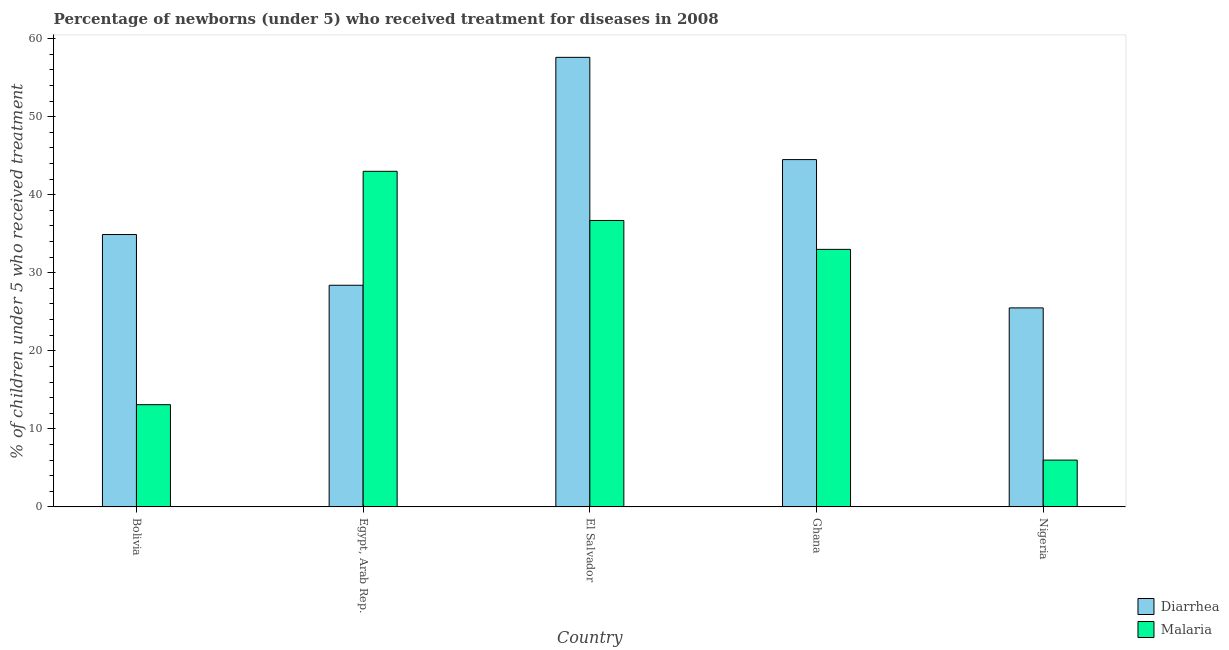How many different coloured bars are there?
Ensure brevity in your answer.  2. How many groups of bars are there?
Your response must be concise. 5. Are the number of bars on each tick of the X-axis equal?
Keep it short and to the point. Yes. What is the label of the 2nd group of bars from the left?
Provide a succinct answer. Egypt, Arab Rep. In how many cases, is the number of bars for a given country not equal to the number of legend labels?
Provide a short and direct response. 0. Across all countries, what is the maximum percentage of children who received treatment for malaria?
Your answer should be compact. 43. In which country was the percentage of children who received treatment for malaria maximum?
Offer a terse response. Egypt, Arab Rep. In which country was the percentage of children who received treatment for diarrhoea minimum?
Offer a very short reply. Nigeria. What is the total percentage of children who received treatment for malaria in the graph?
Provide a succinct answer. 131.8. What is the difference between the percentage of children who received treatment for diarrhoea in Bolivia and that in El Salvador?
Your answer should be very brief. -22.7. What is the difference between the percentage of children who received treatment for malaria in Bolivia and the percentage of children who received treatment for diarrhoea in El Salvador?
Give a very brief answer. -44.5. What is the average percentage of children who received treatment for malaria per country?
Your answer should be very brief. 26.36. What is the difference between the percentage of children who received treatment for malaria and percentage of children who received treatment for diarrhoea in Ghana?
Provide a short and direct response. -11.5. In how many countries, is the percentage of children who received treatment for malaria greater than 22 %?
Make the answer very short. 3. What is the ratio of the percentage of children who received treatment for malaria in El Salvador to that in Ghana?
Your response must be concise. 1.11. Is the difference between the percentage of children who received treatment for malaria in Egypt, Arab Rep. and El Salvador greater than the difference between the percentage of children who received treatment for diarrhoea in Egypt, Arab Rep. and El Salvador?
Provide a short and direct response. Yes. What is the difference between the highest and the second highest percentage of children who received treatment for malaria?
Offer a terse response. 6.3. What is the difference between the highest and the lowest percentage of children who received treatment for diarrhoea?
Provide a succinct answer. 32.1. In how many countries, is the percentage of children who received treatment for malaria greater than the average percentage of children who received treatment for malaria taken over all countries?
Provide a short and direct response. 3. Is the sum of the percentage of children who received treatment for diarrhoea in Bolivia and Ghana greater than the maximum percentage of children who received treatment for malaria across all countries?
Ensure brevity in your answer.  Yes. What does the 2nd bar from the left in Ghana represents?
Keep it short and to the point. Malaria. What does the 1st bar from the right in Nigeria represents?
Your answer should be very brief. Malaria. How many countries are there in the graph?
Provide a succinct answer. 5. Does the graph contain grids?
Provide a short and direct response. No. Where does the legend appear in the graph?
Offer a terse response. Bottom right. How are the legend labels stacked?
Your response must be concise. Vertical. What is the title of the graph?
Ensure brevity in your answer.  Percentage of newborns (under 5) who received treatment for diseases in 2008. Does "Foreign liabilities" appear as one of the legend labels in the graph?
Give a very brief answer. No. What is the label or title of the Y-axis?
Your answer should be very brief. % of children under 5 who received treatment. What is the % of children under 5 who received treatment in Diarrhea in Bolivia?
Your answer should be very brief. 34.9. What is the % of children under 5 who received treatment of Malaria in Bolivia?
Your answer should be very brief. 13.1. What is the % of children under 5 who received treatment in Diarrhea in Egypt, Arab Rep.?
Your answer should be compact. 28.4. What is the % of children under 5 who received treatment of Malaria in Egypt, Arab Rep.?
Ensure brevity in your answer.  43. What is the % of children under 5 who received treatment of Diarrhea in El Salvador?
Provide a succinct answer. 57.6. What is the % of children under 5 who received treatment of Malaria in El Salvador?
Provide a short and direct response. 36.7. What is the % of children under 5 who received treatment in Diarrhea in Ghana?
Your response must be concise. 44.5. What is the % of children under 5 who received treatment of Malaria in Ghana?
Offer a very short reply. 33. Across all countries, what is the maximum % of children under 5 who received treatment of Diarrhea?
Keep it short and to the point. 57.6. Across all countries, what is the minimum % of children under 5 who received treatment of Diarrhea?
Provide a short and direct response. 25.5. What is the total % of children under 5 who received treatment in Diarrhea in the graph?
Your answer should be very brief. 190.9. What is the total % of children under 5 who received treatment in Malaria in the graph?
Offer a terse response. 131.8. What is the difference between the % of children under 5 who received treatment of Diarrhea in Bolivia and that in Egypt, Arab Rep.?
Offer a terse response. 6.5. What is the difference between the % of children under 5 who received treatment in Malaria in Bolivia and that in Egypt, Arab Rep.?
Your response must be concise. -29.9. What is the difference between the % of children under 5 who received treatment in Diarrhea in Bolivia and that in El Salvador?
Provide a short and direct response. -22.7. What is the difference between the % of children under 5 who received treatment in Malaria in Bolivia and that in El Salvador?
Your response must be concise. -23.6. What is the difference between the % of children under 5 who received treatment in Diarrhea in Bolivia and that in Ghana?
Provide a short and direct response. -9.6. What is the difference between the % of children under 5 who received treatment in Malaria in Bolivia and that in Ghana?
Offer a terse response. -19.9. What is the difference between the % of children under 5 who received treatment in Malaria in Bolivia and that in Nigeria?
Your answer should be very brief. 7.1. What is the difference between the % of children under 5 who received treatment of Diarrhea in Egypt, Arab Rep. and that in El Salvador?
Your answer should be compact. -29.2. What is the difference between the % of children under 5 who received treatment of Diarrhea in Egypt, Arab Rep. and that in Ghana?
Ensure brevity in your answer.  -16.1. What is the difference between the % of children under 5 who received treatment of Malaria in Egypt, Arab Rep. and that in Ghana?
Keep it short and to the point. 10. What is the difference between the % of children under 5 who received treatment of Diarrhea in El Salvador and that in Ghana?
Ensure brevity in your answer.  13.1. What is the difference between the % of children under 5 who received treatment of Malaria in El Salvador and that in Ghana?
Your response must be concise. 3.7. What is the difference between the % of children under 5 who received treatment of Diarrhea in El Salvador and that in Nigeria?
Keep it short and to the point. 32.1. What is the difference between the % of children under 5 who received treatment in Malaria in El Salvador and that in Nigeria?
Your answer should be compact. 30.7. What is the difference between the % of children under 5 who received treatment in Diarrhea in Ghana and that in Nigeria?
Your response must be concise. 19. What is the difference between the % of children under 5 who received treatment of Malaria in Ghana and that in Nigeria?
Provide a succinct answer. 27. What is the difference between the % of children under 5 who received treatment in Diarrhea in Bolivia and the % of children under 5 who received treatment in Malaria in Egypt, Arab Rep.?
Make the answer very short. -8.1. What is the difference between the % of children under 5 who received treatment in Diarrhea in Bolivia and the % of children under 5 who received treatment in Malaria in Ghana?
Provide a succinct answer. 1.9. What is the difference between the % of children under 5 who received treatment in Diarrhea in Bolivia and the % of children under 5 who received treatment in Malaria in Nigeria?
Give a very brief answer. 28.9. What is the difference between the % of children under 5 who received treatment of Diarrhea in Egypt, Arab Rep. and the % of children under 5 who received treatment of Malaria in El Salvador?
Your answer should be compact. -8.3. What is the difference between the % of children under 5 who received treatment in Diarrhea in Egypt, Arab Rep. and the % of children under 5 who received treatment in Malaria in Ghana?
Your answer should be compact. -4.6. What is the difference between the % of children under 5 who received treatment in Diarrhea in Egypt, Arab Rep. and the % of children under 5 who received treatment in Malaria in Nigeria?
Provide a short and direct response. 22.4. What is the difference between the % of children under 5 who received treatment in Diarrhea in El Salvador and the % of children under 5 who received treatment in Malaria in Ghana?
Ensure brevity in your answer.  24.6. What is the difference between the % of children under 5 who received treatment of Diarrhea in El Salvador and the % of children under 5 who received treatment of Malaria in Nigeria?
Give a very brief answer. 51.6. What is the difference between the % of children under 5 who received treatment of Diarrhea in Ghana and the % of children under 5 who received treatment of Malaria in Nigeria?
Provide a succinct answer. 38.5. What is the average % of children under 5 who received treatment in Diarrhea per country?
Provide a succinct answer. 38.18. What is the average % of children under 5 who received treatment of Malaria per country?
Provide a short and direct response. 26.36. What is the difference between the % of children under 5 who received treatment in Diarrhea and % of children under 5 who received treatment in Malaria in Bolivia?
Provide a succinct answer. 21.8. What is the difference between the % of children under 5 who received treatment in Diarrhea and % of children under 5 who received treatment in Malaria in Egypt, Arab Rep.?
Provide a short and direct response. -14.6. What is the difference between the % of children under 5 who received treatment of Diarrhea and % of children under 5 who received treatment of Malaria in El Salvador?
Give a very brief answer. 20.9. What is the difference between the % of children under 5 who received treatment in Diarrhea and % of children under 5 who received treatment in Malaria in Ghana?
Provide a short and direct response. 11.5. What is the ratio of the % of children under 5 who received treatment of Diarrhea in Bolivia to that in Egypt, Arab Rep.?
Provide a succinct answer. 1.23. What is the ratio of the % of children under 5 who received treatment of Malaria in Bolivia to that in Egypt, Arab Rep.?
Ensure brevity in your answer.  0.3. What is the ratio of the % of children under 5 who received treatment in Diarrhea in Bolivia to that in El Salvador?
Your answer should be compact. 0.61. What is the ratio of the % of children under 5 who received treatment of Malaria in Bolivia to that in El Salvador?
Make the answer very short. 0.36. What is the ratio of the % of children under 5 who received treatment in Diarrhea in Bolivia to that in Ghana?
Ensure brevity in your answer.  0.78. What is the ratio of the % of children under 5 who received treatment of Malaria in Bolivia to that in Ghana?
Provide a short and direct response. 0.4. What is the ratio of the % of children under 5 who received treatment in Diarrhea in Bolivia to that in Nigeria?
Keep it short and to the point. 1.37. What is the ratio of the % of children under 5 who received treatment of Malaria in Bolivia to that in Nigeria?
Keep it short and to the point. 2.18. What is the ratio of the % of children under 5 who received treatment in Diarrhea in Egypt, Arab Rep. to that in El Salvador?
Your response must be concise. 0.49. What is the ratio of the % of children under 5 who received treatment of Malaria in Egypt, Arab Rep. to that in El Salvador?
Offer a terse response. 1.17. What is the ratio of the % of children under 5 who received treatment in Diarrhea in Egypt, Arab Rep. to that in Ghana?
Give a very brief answer. 0.64. What is the ratio of the % of children under 5 who received treatment in Malaria in Egypt, Arab Rep. to that in Ghana?
Offer a very short reply. 1.3. What is the ratio of the % of children under 5 who received treatment of Diarrhea in Egypt, Arab Rep. to that in Nigeria?
Offer a terse response. 1.11. What is the ratio of the % of children under 5 who received treatment of Malaria in Egypt, Arab Rep. to that in Nigeria?
Offer a terse response. 7.17. What is the ratio of the % of children under 5 who received treatment in Diarrhea in El Salvador to that in Ghana?
Provide a short and direct response. 1.29. What is the ratio of the % of children under 5 who received treatment of Malaria in El Salvador to that in Ghana?
Make the answer very short. 1.11. What is the ratio of the % of children under 5 who received treatment in Diarrhea in El Salvador to that in Nigeria?
Provide a succinct answer. 2.26. What is the ratio of the % of children under 5 who received treatment in Malaria in El Salvador to that in Nigeria?
Keep it short and to the point. 6.12. What is the ratio of the % of children under 5 who received treatment of Diarrhea in Ghana to that in Nigeria?
Provide a short and direct response. 1.75. What is the difference between the highest and the lowest % of children under 5 who received treatment in Diarrhea?
Your answer should be very brief. 32.1. What is the difference between the highest and the lowest % of children under 5 who received treatment of Malaria?
Your answer should be very brief. 37. 